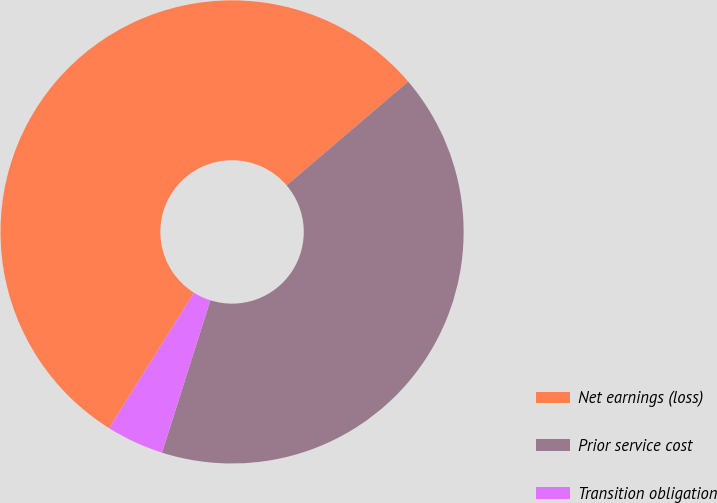Convert chart to OTSL. <chart><loc_0><loc_0><loc_500><loc_500><pie_chart><fcel>Net earnings (loss)<fcel>Prior service cost<fcel>Transition obligation<nl><fcel>54.85%<fcel>41.14%<fcel>4.02%<nl></chart> 